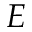Convert formula to latex. <formula><loc_0><loc_0><loc_500><loc_500>E</formula> 